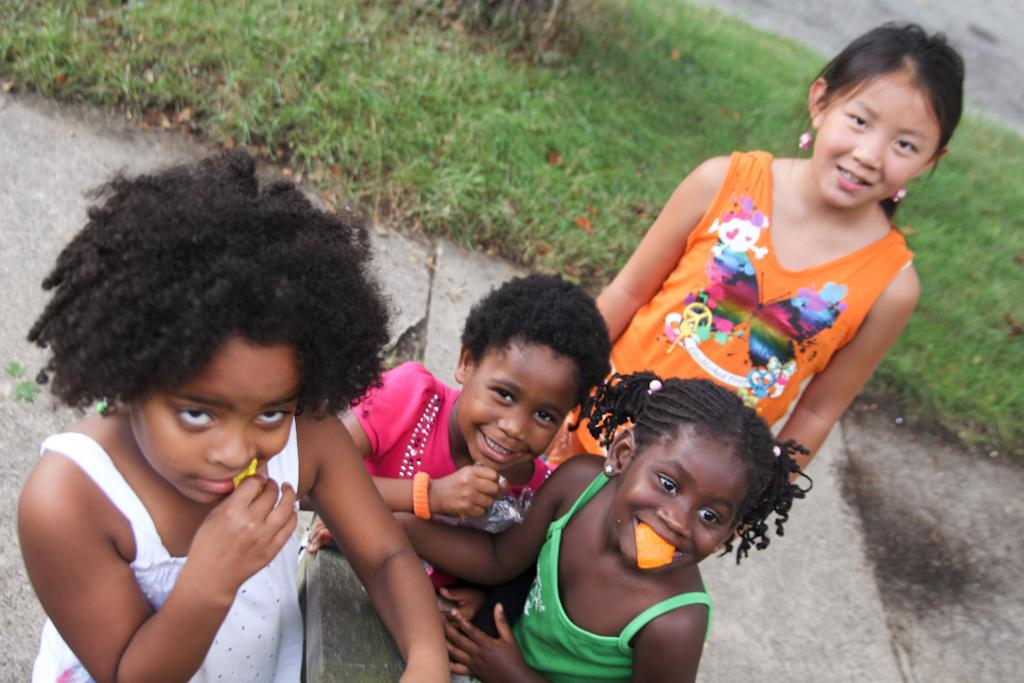How many kids are present in the image? There are four kids in the image. What is the facial expression of some of the kids? Some of the kids are smiling. What type of natural environment can be seen in the background of the image? There is grass visible in the background of the image. What type of milk is being used as an example in the image? There is no milk or example present in the image; it features four kids and grass in the background. What type of machine can be seen in the image? There is no machine present in the image. 